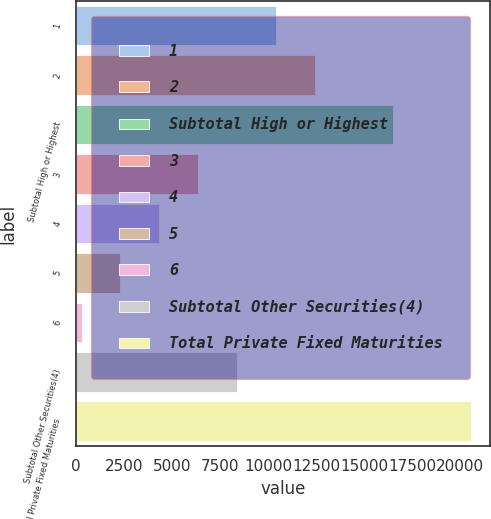Convert chart. <chart><loc_0><loc_0><loc_500><loc_500><bar_chart><fcel>1<fcel>2<fcel>Subtotal High or Highest<fcel>3<fcel>4<fcel>5<fcel>6<fcel>Subtotal Other Securities(4)<fcel>Total Private Fixed Maturities<nl><fcel>10422.5<fcel>12447.4<fcel>16491<fcel>6372.7<fcel>4347.8<fcel>2322.9<fcel>298<fcel>8397.6<fcel>20547<nl></chart> 